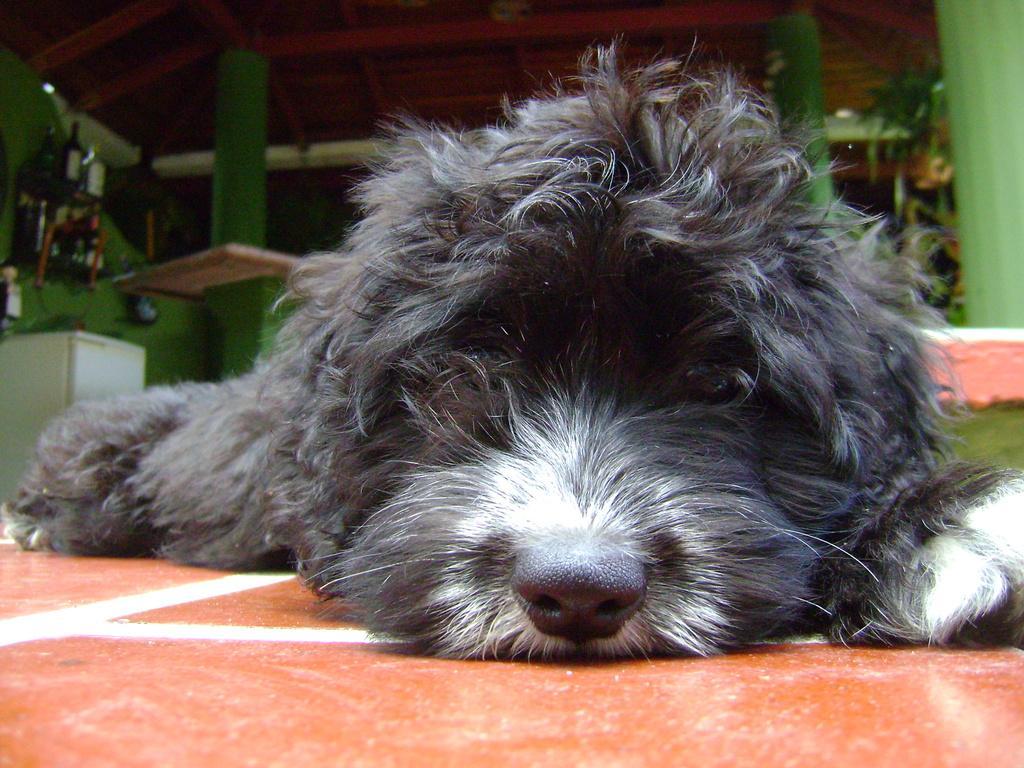In one or two sentences, can you explain what this image depicts? At the bottom of this image, there is a dog in black and white color combination, lying on an orange color floor. In the background, there are green color pillars and there are other objects. 